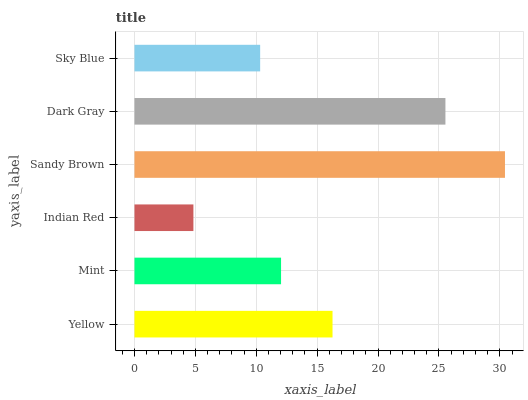Is Indian Red the minimum?
Answer yes or no. Yes. Is Sandy Brown the maximum?
Answer yes or no. Yes. Is Mint the minimum?
Answer yes or no. No. Is Mint the maximum?
Answer yes or no. No. Is Yellow greater than Mint?
Answer yes or no. Yes. Is Mint less than Yellow?
Answer yes or no. Yes. Is Mint greater than Yellow?
Answer yes or no. No. Is Yellow less than Mint?
Answer yes or no. No. Is Yellow the high median?
Answer yes or no. Yes. Is Mint the low median?
Answer yes or no. Yes. Is Mint the high median?
Answer yes or no. No. Is Sandy Brown the low median?
Answer yes or no. No. 